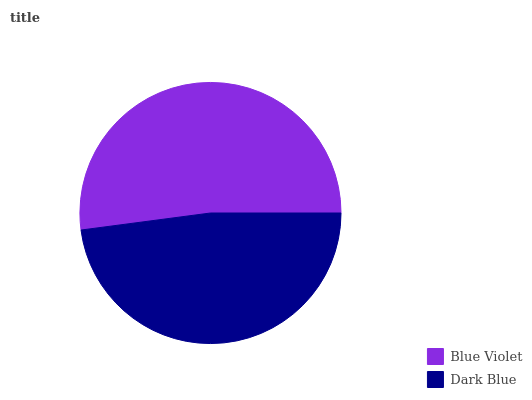Is Dark Blue the minimum?
Answer yes or no. Yes. Is Blue Violet the maximum?
Answer yes or no. Yes. Is Dark Blue the maximum?
Answer yes or no. No. Is Blue Violet greater than Dark Blue?
Answer yes or no. Yes. Is Dark Blue less than Blue Violet?
Answer yes or no. Yes. Is Dark Blue greater than Blue Violet?
Answer yes or no. No. Is Blue Violet less than Dark Blue?
Answer yes or no. No. Is Blue Violet the high median?
Answer yes or no. Yes. Is Dark Blue the low median?
Answer yes or no. Yes. Is Dark Blue the high median?
Answer yes or no. No. Is Blue Violet the low median?
Answer yes or no. No. 